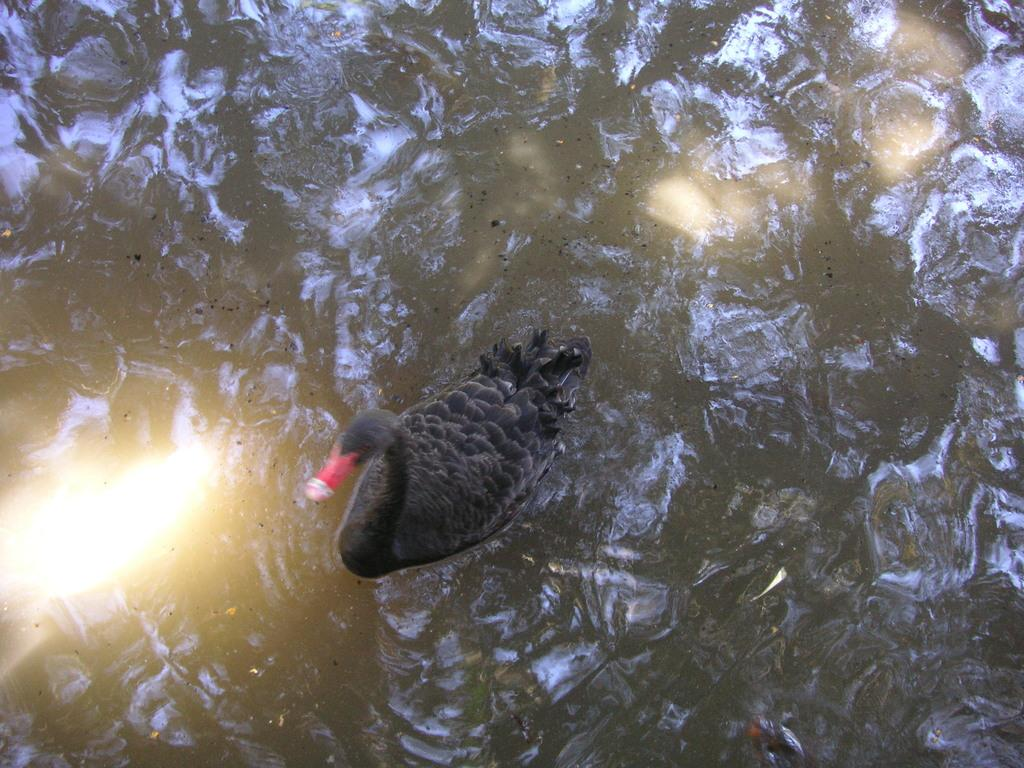What is the main subject of the image? The main subject of the image is a duck. Where is the image taken? The image is taken near a river. What color is the duck in the image? The duck is grey in color. What type of drum can be heard playing in the background of the image? There is no drum or sound present in the image; it is a still photograph of a duck near a river. 